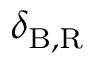Convert formula to latex. <formula><loc_0><loc_0><loc_500><loc_500>\delta _ { B , R }</formula> 